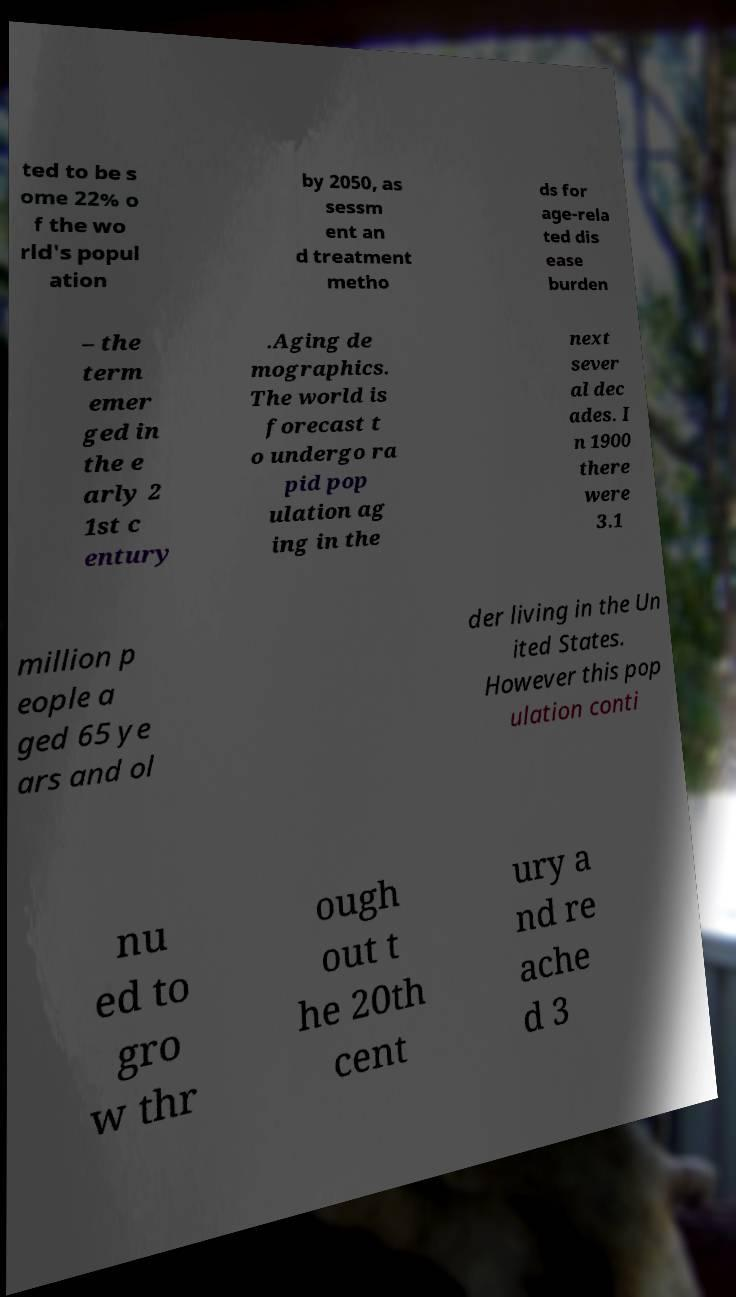Could you extract and type out the text from this image? ted to be s ome 22% o f the wo rld's popul ation by 2050, as sessm ent an d treatment metho ds for age-rela ted dis ease burden – the term emer ged in the e arly 2 1st c entury .Aging de mographics. The world is forecast t o undergo ra pid pop ulation ag ing in the next sever al dec ades. I n 1900 there were 3.1 million p eople a ged 65 ye ars and ol der living in the Un ited States. However this pop ulation conti nu ed to gro w thr ough out t he 20th cent ury a nd re ache d 3 